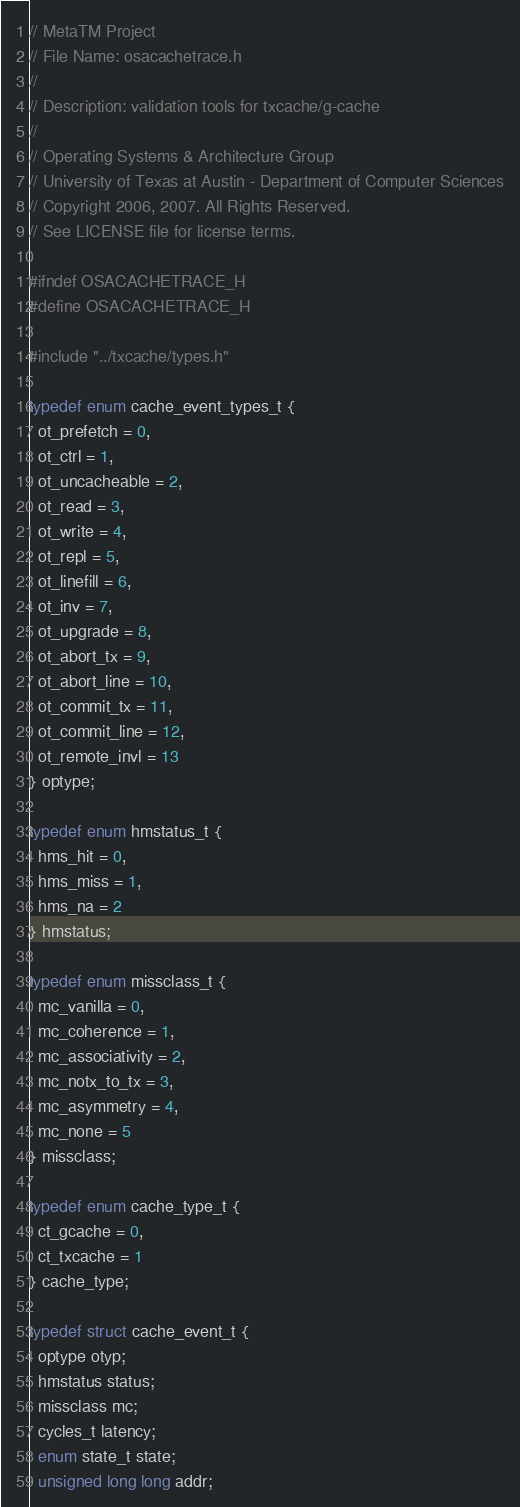Convert code to text. <code><loc_0><loc_0><loc_500><loc_500><_C_>// MetaTM Project
// File Name: osacachetrace.h
//
// Description: validation tools for txcache/g-cache
//
// Operating Systems & Architecture Group
// University of Texas at Austin - Department of Computer Sciences
// Copyright 2006, 2007. All Rights Reserved.
// See LICENSE file for license terms.

#ifndef OSACACHETRACE_H
#define OSACACHETRACE_H

#include "../txcache/types.h"

typedef enum cache_event_types_t {
  ot_prefetch = 0,
  ot_ctrl = 1,
  ot_uncacheable = 2,
  ot_read = 3,
  ot_write = 4,
  ot_repl = 5,
  ot_linefill = 6,
  ot_inv = 7,
  ot_upgrade = 8,
  ot_abort_tx = 9,
  ot_abort_line = 10,
  ot_commit_tx = 11,
  ot_commit_line = 12,
  ot_remote_invl = 13
} optype;

typedef enum hmstatus_t {
  hms_hit = 0,
  hms_miss = 1,
  hms_na = 2
} hmstatus;

typedef enum missclass_t {
  mc_vanilla = 0,
  mc_coherence = 1,
  mc_associativity = 2,
  mc_notx_to_tx = 3,
  mc_asymmetry = 4,
  mc_none = 5
} missclass;

typedef enum cache_type_t {
  ct_gcache = 0,
  ct_txcache = 1
} cache_type;

typedef struct cache_event_t {
  optype otyp;
  hmstatus status;
  missclass mc;
  cycles_t latency;
  enum state_t state;
  unsigned long long addr;</code> 